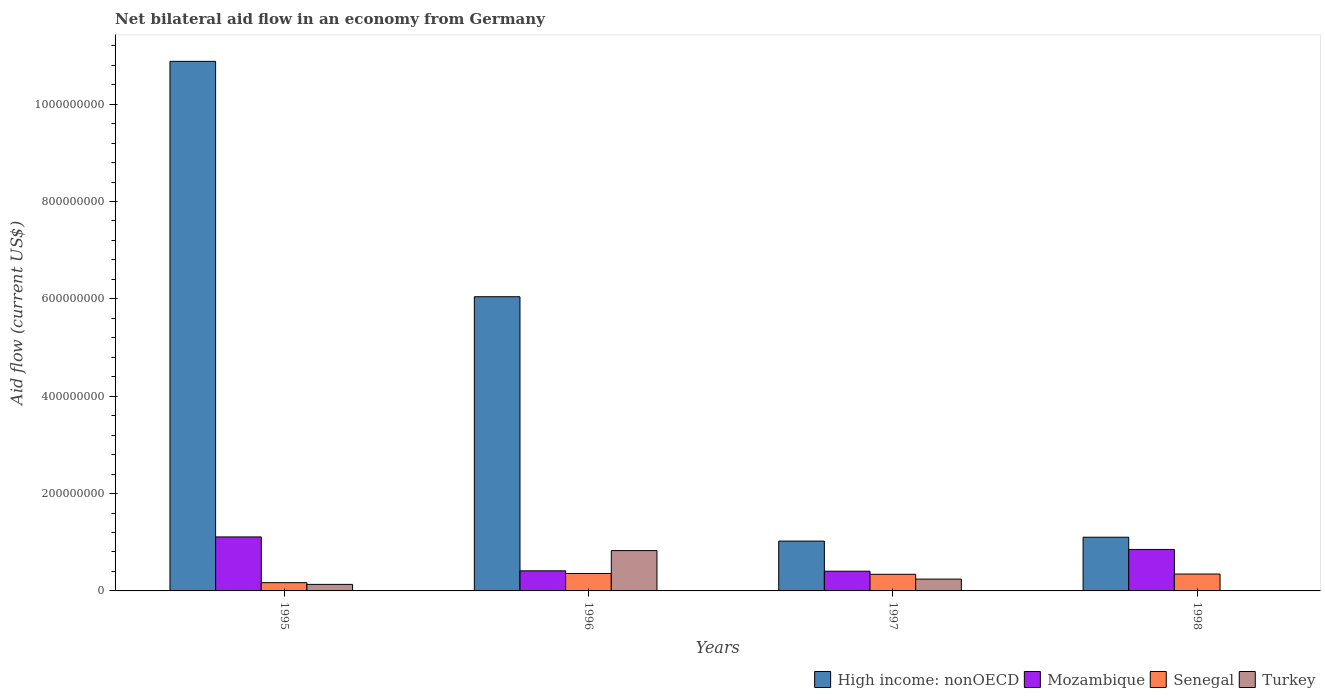How many groups of bars are there?
Your answer should be compact. 4. Are the number of bars per tick equal to the number of legend labels?
Keep it short and to the point. No. Are the number of bars on each tick of the X-axis equal?
Provide a succinct answer. No. How many bars are there on the 1st tick from the left?
Offer a terse response. 4. How many bars are there on the 4th tick from the right?
Your answer should be very brief. 4. What is the net bilateral aid flow in Mozambique in 1998?
Keep it short and to the point. 8.52e+07. Across all years, what is the maximum net bilateral aid flow in Turkey?
Give a very brief answer. 8.28e+07. Across all years, what is the minimum net bilateral aid flow in Senegal?
Provide a succinct answer. 1.70e+07. What is the total net bilateral aid flow in Turkey in the graph?
Keep it short and to the point. 1.21e+08. What is the difference between the net bilateral aid flow in Senegal in 1995 and that in 1996?
Your response must be concise. -1.89e+07. What is the difference between the net bilateral aid flow in High income: nonOECD in 1997 and the net bilateral aid flow in Senegal in 1996?
Keep it short and to the point. 6.66e+07. What is the average net bilateral aid flow in Senegal per year?
Your response must be concise. 3.04e+07. In the year 1995, what is the difference between the net bilateral aid flow in Senegal and net bilateral aid flow in High income: nonOECD?
Make the answer very short. -1.07e+09. What is the ratio of the net bilateral aid flow in Senegal in 1995 to that in 1996?
Provide a short and direct response. 0.47. Is the net bilateral aid flow in Mozambique in 1995 less than that in 1998?
Offer a very short reply. No. What is the difference between the highest and the second highest net bilateral aid flow in Mozambique?
Offer a terse response. 2.57e+07. What is the difference between the highest and the lowest net bilateral aid flow in Turkey?
Your answer should be very brief. 8.28e+07. In how many years, is the net bilateral aid flow in High income: nonOECD greater than the average net bilateral aid flow in High income: nonOECD taken over all years?
Offer a terse response. 2. What is the difference between two consecutive major ticks on the Y-axis?
Offer a terse response. 2.00e+08. Are the values on the major ticks of Y-axis written in scientific E-notation?
Offer a terse response. No. Where does the legend appear in the graph?
Provide a succinct answer. Bottom right. How many legend labels are there?
Ensure brevity in your answer.  4. What is the title of the graph?
Provide a succinct answer. Net bilateral aid flow in an economy from Germany. Does "Azerbaijan" appear as one of the legend labels in the graph?
Keep it short and to the point. No. What is the Aid flow (current US$) in High income: nonOECD in 1995?
Offer a terse response. 1.09e+09. What is the Aid flow (current US$) of Mozambique in 1995?
Keep it short and to the point. 1.11e+08. What is the Aid flow (current US$) of Senegal in 1995?
Your response must be concise. 1.70e+07. What is the Aid flow (current US$) of Turkey in 1995?
Your answer should be compact. 1.34e+07. What is the Aid flow (current US$) in High income: nonOECD in 1996?
Ensure brevity in your answer.  6.04e+08. What is the Aid flow (current US$) in Mozambique in 1996?
Your answer should be compact. 4.13e+07. What is the Aid flow (current US$) in Senegal in 1996?
Your response must be concise. 3.58e+07. What is the Aid flow (current US$) of Turkey in 1996?
Give a very brief answer. 8.28e+07. What is the Aid flow (current US$) of High income: nonOECD in 1997?
Your answer should be compact. 1.02e+08. What is the Aid flow (current US$) in Mozambique in 1997?
Offer a terse response. 4.05e+07. What is the Aid flow (current US$) of Senegal in 1997?
Offer a terse response. 3.42e+07. What is the Aid flow (current US$) in Turkey in 1997?
Offer a very short reply. 2.43e+07. What is the Aid flow (current US$) of High income: nonOECD in 1998?
Your answer should be compact. 1.10e+08. What is the Aid flow (current US$) of Mozambique in 1998?
Offer a terse response. 8.52e+07. What is the Aid flow (current US$) of Senegal in 1998?
Provide a short and direct response. 3.47e+07. What is the Aid flow (current US$) in Turkey in 1998?
Your answer should be very brief. 0. Across all years, what is the maximum Aid flow (current US$) of High income: nonOECD?
Provide a succinct answer. 1.09e+09. Across all years, what is the maximum Aid flow (current US$) of Mozambique?
Offer a very short reply. 1.11e+08. Across all years, what is the maximum Aid flow (current US$) of Senegal?
Your answer should be very brief. 3.58e+07. Across all years, what is the maximum Aid flow (current US$) of Turkey?
Your answer should be compact. 8.28e+07. Across all years, what is the minimum Aid flow (current US$) of High income: nonOECD?
Provide a succinct answer. 1.02e+08. Across all years, what is the minimum Aid flow (current US$) in Mozambique?
Keep it short and to the point. 4.05e+07. Across all years, what is the minimum Aid flow (current US$) in Senegal?
Provide a succinct answer. 1.70e+07. Across all years, what is the minimum Aid flow (current US$) of Turkey?
Make the answer very short. 0. What is the total Aid flow (current US$) of High income: nonOECD in the graph?
Ensure brevity in your answer.  1.90e+09. What is the total Aid flow (current US$) in Mozambique in the graph?
Provide a succinct answer. 2.78e+08. What is the total Aid flow (current US$) in Senegal in the graph?
Ensure brevity in your answer.  1.22e+08. What is the total Aid flow (current US$) in Turkey in the graph?
Provide a succinct answer. 1.21e+08. What is the difference between the Aid flow (current US$) of High income: nonOECD in 1995 and that in 1996?
Your response must be concise. 4.84e+08. What is the difference between the Aid flow (current US$) in Mozambique in 1995 and that in 1996?
Make the answer very short. 6.96e+07. What is the difference between the Aid flow (current US$) of Senegal in 1995 and that in 1996?
Give a very brief answer. -1.89e+07. What is the difference between the Aid flow (current US$) in Turkey in 1995 and that in 1996?
Offer a very short reply. -6.94e+07. What is the difference between the Aid flow (current US$) in High income: nonOECD in 1995 and that in 1997?
Your answer should be very brief. 9.85e+08. What is the difference between the Aid flow (current US$) of Mozambique in 1995 and that in 1997?
Provide a short and direct response. 7.04e+07. What is the difference between the Aid flow (current US$) in Senegal in 1995 and that in 1997?
Keep it short and to the point. -1.72e+07. What is the difference between the Aid flow (current US$) in Turkey in 1995 and that in 1997?
Your response must be concise. -1.08e+07. What is the difference between the Aid flow (current US$) in High income: nonOECD in 1995 and that in 1998?
Your answer should be compact. 9.78e+08. What is the difference between the Aid flow (current US$) in Mozambique in 1995 and that in 1998?
Ensure brevity in your answer.  2.57e+07. What is the difference between the Aid flow (current US$) of Senegal in 1995 and that in 1998?
Your response must be concise. -1.77e+07. What is the difference between the Aid flow (current US$) of High income: nonOECD in 1996 and that in 1997?
Provide a short and direct response. 5.02e+08. What is the difference between the Aid flow (current US$) of Mozambique in 1996 and that in 1997?
Provide a short and direct response. 7.80e+05. What is the difference between the Aid flow (current US$) in Senegal in 1996 and that in 1997?
Ensure brevity in your answer.  1.65e+06. What is the difference between the Aid flow (current US$) of Turkey in 1996 and that in 1997?
Offer a very short reply. 5.86e+07. What is the difference between the Aid flow (current US$) in High income: nonOECD in 1996 and that in 1998?
Your answer should be very brief. 4.94e+08. What is the difference between the Aid flow (current US$) in Mozambique in 1996 and that in 1998?
Provide a succinct answer. -4.39e+07. What is the difference between the Aid flow (current US$) of Senegal in 1996 and that in 1998?
Your response must be concise. 1.14e+06. What is the difference between the Aid flow (current US$) in High income: nonOECD in 1997 and that in 1998?
Offer a very short reply. -7.90e+06. What is the difference between the Aid flow (current US$) in Mozambique in 1997 and that in 1998?
Your answer should be very brief. -4.47e+07. What is the difference between the Aid flow (current US$) in Senegal in 1997 and that in 1998?
Your answer should be compact. -5.10e+05. What is the difference between the Aid flow (current US$) of High income: nonOECD in 1995 and the Aid flow (current US$) of Mozambique in 1996?
Provide a short and direct response. 1.05e+09. What is the difference between the Aid flow (current US$) in High income: nonOECD in 1995 and the Aid flow (current US$) in Senegal in 1996?
Ensure brevity in your answer.  1.05e+09. What is the difference between the Aid flow (current US$) of High income: nonOECD in 1995 and the Aid flow (current US$) of Turkey in 1996?
Your response must be concise. 1.01e+09. What is the difference between the Aid flow (current US$) in Mozambique in 1995 and the Aid flow (current US$) in Senegal in 1996?
Your response must be concise. 7.51e+07. What is the difference between the Aid flow (current US$) of Mozambique in 1995 and the Aid flow (current US$) of Turkey in 1996?
Provide a succinct answer. 2.81e+07. What is the difference between the Aid flow (current US$) in Senegal in 1995 and the Aid flow (current US$) in Turkey in 1996?
Provide a succinct answer. -6.59e+07. What is the difference between the Aid flow (current US$) in High income: nonOECD in 1995 and the Aid flow (current US$) in Mozambique in 1997?
Make the answer very short. 1.05e+09. What is the difference between the Aid flow (current US$) of High income: nonOECD in 1995 and the Aid flow (current US$) of Senegal in 1997?
Offer a terse response. 1.05e+09. What is the difference between the Aid flow (current US$) of High income: nonOECD in 1995 and the Aid flow (current US$) of Turkey in 1997?
Your answer should be very brief. 1.06e+09. What is the difference between the Aid flow (current US$) in Mozambique in 1995 and the Aid flow (current US$) in Senegal in 1997?
Give a very brief answer. 7.67e+07. What is the difference between the Aid flow (current US$) in Mozambique in 1995 and the Aid flow (current US$) in Turkey in 1997?
Your response must be concise. 8.66e+07. What is the difference between the Aid flow (current US$) in Senegal in 1995 and the Aid flow (current US$) in Turkey in 1997?
Provide a short and direct response. -7.31e+06. What is the difference between the Aid flow (current US$) of High income: nonOECD in 1995 and the Aid flow (current US$) of Mozambique in 1998?
Your response must be concise. 1.00e+09. What is the difference between the Aid flow (current US$) in High income: nonOECD in 1995 and the Aid flow (current US$) in Senegal in 1998?
Ensure brevity in your answer.  1.05e+09. What is the difference between the Aid flow (current US$) in Mozambique in 1995 and the Aid flow (current US$) in Senegal in 1998?
Your answer should be compact. 7.62e+07. What is the difference between the Aid flow (current US$) in High income: nonOECD in 1996 and the Aid flow (current US$) in Mozambique in 1997?
Your answer should be very brief. 5.64e+08. What is the difference between the Aid flow (current US$) in High income: nonOECD in 1996 and the Aid flow (current US$) in Senegal in 1997?
Make the answer very short. 5.70e+08. What is the difference between the Aid flow (current US$) in High income: nonOECD in 1996 and the Aid flow (current US$) in Turkey in 1997?
Keep it short and to the point. 5.80e+08. What is the difference between the Aid flow (current US$) in Mozambique in 1996 and the Aid flow (current US$) in Senegal in 1997?
Offer a very short reply. 7.09e+06. What is the difference between the Aid flow (current US$) of Mozambique in 1996 and the Aid flow (current US$) of Turkey in 1997?
Offer a terse response. 1.70e+07. What is the difference between the Aid flow (current US$) of Senegal in 1996 and the Aid flow (current US$) of Turkey in 1997?
Make the answer very short. 1.16e+07. What is the difference between the Aid flow (current US$) in High income: nonOECD in 1996 and the Aid flow (current US$) in Mozambique in 1998?
Keep it short and to the point. 5.19e+08. What is the difference between the Aid flow (current US$) in High income: nonOECD in 1996 and the Aid flow (current US$) in Senegal in 1998?
Offer a terse response. 5.70e+08. What is the difference between the Aid flow (current US$) in Mozambique in 1996 and the Aid flow (current US$) in Senegal in 1998?
Your answer should be very brief. 6.58e+06. What is the difference between the Aid flow (current US$) of High income: nonOECD in 1997 and the Aid flow (current US$) of Mozambique in 1998?
Your answer should be compact. 1.72e+07. What is the difference between the Aid flow (current US$) of High income: nonOECD in 1997 and the Aid flow (current US$) of Senegal in 1998?
Provide a short and direct response. 6.77e+07. What is the difference between the Aid flow (current US$) in Mozambique in 1997 and the Aid flow (current US$) in Senegal in 1998?
Provide a succinct answer. 5.80e+06. What is the average Aid flow (current US$) of High income: nonOECD per year?
Provide a short and direct response. 4.76e+08. What is the average Aid flow (current US$) in Mozambique per year?
Make the answer very short. 6.95e+07. What is the average Aid flow (current US$) in Senegal per year?
Give a very brief answer. 3.04e+07. What is the average Aid flow (current US$) in Turkey per year?
Your answer should be compact. 3.01e+07. In the year 1995, what is the difference between the Aid flow (current US$) of High income: nonOECD and Aid flow (current US$) of Mozambique?
Ensure brevity in your answer.  9.77e+08. In the year 1995, what is the difference between the Aid flow (current US$) of High income: nonOECD and Aid flow (current US$) of Senegal?
Provide a succinct answer. 1.07e+09. In the year 1995, what is the difference between the Aid flow (current US$) in High income: nonOECD and Aid flow (current US$) in Turkey?
Your answer should be very brief. 1.07e+09. In the year 1995, what is the difference between the Aid flow (current US$) in Mozambique and Aid flow (current US$) in Senegal?
Keep it short and to the point. 9.39e+07. In the year 1995, what is the difference between the Aid flow (current US$) of Mozambique and Aid flow (current US$) of Turkey?
Offer a terse response. 9.75e+07. In the year 1995, what is the difference between the Aid flow (current US$) in Senegal and Aid flow (current US$) in Turkey?
Keep it short and to the point. 3.53e+06. In the year 1996, what is the difference between the Aid flow (current US$) in High income: nonOECD and Aid flow (current US$) in Mozambique?
Your response must be concise. 5.63e+08. In the year 1996, what is the difference between the Aid flow (current US$) in High income: nonOECD and Aid flow (current US$) in Senegal?
Provide a succinct answer. 5.69e+08. In the year 1996, what is the difference between the Aid flow (current US$) in High income: nonOECD and Aid flow (current US$) in Turkey?
Offer a terse response. 5.22e+08. In the year 1996, what is the difference between the Aid flow (current US$) in Mozambique and Aid flow (current US$) in Senegal?
Offer a very short reply. 5.44e+06. In the year 1996, what is the difference between the Aid flow (current US$) in Mozambique and Aid flow (current US$) in Turkey?
Give a very brief answer. -4.16e+07. In the year 1996, what is the difference between the Aid flow (current US$) in Senegal and Aid flow (current US$) in Turkey?
Offer a very short reply. -4.70e+07. In the year 1997, what is the difference between the Aid flow (current US$) of High income: nonOECD and Aid flow (current US$) of Mozambique?
Your answer should be very brief. 6.19e+07. In the year 1997, what is the difference between the Aid flow (current US$) of High income: nonOECD and Aid flow (current US$) of Senegal?
Keep it short and to the point. 6.82e+07. In the year 1997, what is the difference between the Aid flow (current US$) of High income: nonOECD and Aid flow (current US$) of Turkey?
Give a very brief answer. 7.81e+07. In the year 1997, what is the difference between the Aid flow (current US$) in Mozambique and Aid flow (current US$) in Senegal?
Keep it short and to the point. 6.31e+06. In the year 1997, what is the difference between the Aid flow (current US$) of Mozambique and Aid flow (current US$) of Turkey?
Keep it short and to the point. 1.62e+07. In the year 1997, what is the difference between the Aid flow (current US$) of Senegal and Aid flow (current US$) of Turkey?
Offer a terse response. 9.91e+06. In the year 1998, what is the difference between the Aid flow (current US$) in High income: nonOECD and Aid flow (current US$) in Mozambique?
Keep it short and to the point. 2.51e+07. In the year 1998, what is the difference between the Aid flow (current US$) of High income: nonOECD and Aid flow (current US$) of Senegal?
Make the answer very short. 7.56e+07. In the year 1998, what is the difference between the Aid flow (current US$) in Mozambique and Aid flow (current US$) in Senegal?
Give a very brief answer. 5.05e+07. What is the ratio of the Aid flow (current US$) in High income: nonOECD in 1995 to that in 1996?
Offer a very short reply. 1.8. What is the ratio of the Aid flow (current US$) in Mozambique in 1995 to that in 1996?
Provide a short and direct response. 2.69. What is the ratio of the Aid flow (current US$) of Senegal in 1995 to that in 1996?
Make the answer very short. 0.47. What is the ratio of the Aid flow (current US$) of Turkey in 1995 to that in 1996?
Your answer should be compact. 0.16. What is the ratio of the Aid flow (current US$) in High income: nonOECD in 1995 to that in 1997?
Provide a short and direct response. 10.62. What is the ratio of the Aid flow (current US$) of Mozambique in 1995 to that in 1997?
Make the answer very short. 2.74. What is the ratio of the Aid flow (current US$) in Senegal in 1995 to that in 1997?
Offer a terse response. 0.5. What is the ratio of the Aid flow (current US$) of Turkey in 1995 to that in 1997?
Make the answer very short. 0.55. What is the ratio of the Aid flow (current US$) of High income: nonOECD in 1995 to that in 1998?
Provide a short and direct response. 9.86. What is the ratio of the Aid flow (current US$) of Mozambique in 1995 to that in 1998?
Your answer should be compact. 1.3. What is the ratio of the Aid flow (current US$) of Senegal in 1995 to that in 1998?
Your answer should be compact. 0.49. What is the ratio of the Aid flow (current US$) of High income: nonOECD in 1996 to that in 1997?
Your answer should be very brief. 5.9. What is the ratio of the Aid flow (current US$) in Mozambique in 1996 to that in 1997?
Give a very brief answer. 1.02. What is the ratio of the Aid flow (current US$) in Senegal in 1996 to that in 1997?
Provide a short and direct response. 1.05. What is the ratio of the Aid flow (current US$) in Turkey in 1996 to that in 1997?
Make the answer very short. 3.41. What is the ratio of the Aid flow (current US$) of High income: nonOECD in 1996 to that in 1998?
Give a very brief answer. 5.48. What is the ratio of the Aid flow (current US$) in Mozambique in 1996 to that in 1998?
Provide a short and direct response. 0.48. What is the ratio of the Aid flow (current US$) in Senegal in 1996 to that in 1998?
Provide a short and direct response. 1.03. What is the ratio of the Aid flow (current US$) in High income: nonOECD in 1997 to that in 1998?
Your answer should be very brief. 0.93. What is the ratio of the Aid flow (current US$) of Mozambique in 1997 to that in 1998?
Provide a short and direct response. 0.48. What is the ratio of the Aid flow (current US$) of Senegal in 1997 to that in 1998?
Your answer should be very brief. 0.99. What is the difference between the highest and the second highest Aid flow (current US$) in High income: nonOECD?
Your answer should be compact. 4.84e+08. What is the difference between the highest and the second highest Aid flow (current US$) in Mozambique?
Your response must be concise. 2.57e+07. What is the difference between the highest and the second highest Aid flow (current US$) of Senegal?
Provide a short and direct response. 1.14e+06. What is the difference between the highest and the second highest Aid flow (current US$) in Turkey?
Provide a short and direct response. 5.86e+07. What is the difference between the highest and the lowest Aid flow (current US$) of High income: nonOECD?
Provide a short and direct response. 9.85e+08. What is the difference between the highest and the lowest Aid flow (current US$) in Mozambique?
Offer a very short reply. 7.04e+07. What is the difference between the highest and the lowest Aid flow (current US$) of Senegal?
Make the answer very short. 1.89e+07. What is the difference between the highest and the lowest Aid flow (current US$) in Turkey?
Your response must be concise. 8.28e+07. 